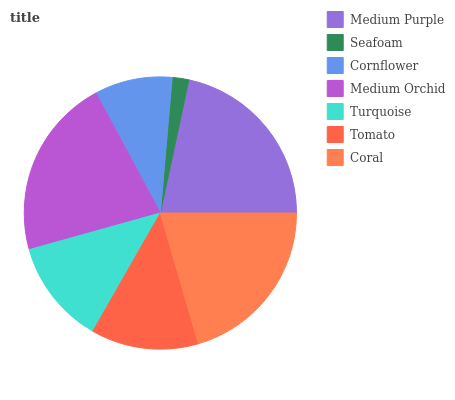Is Seafoam the minimum?
Answer yes or no. Yes. Is Medium Purple the maximum?
Answer yes or no. Yes. Is Cornflower the minimum?
Answer yes or no. No. Is Cornflower the maximum?
Answer yes or no. No. Is Cornflower greater than Seafoam?
Answer yes or no. Yes. Is Seafoam less than Cornflower?
Answer yes or no. Yes. Is Seafoam greater than Cornflower?
Answer yes or no. No. Is Cornflower less than Seafoam?
Answer yes or no. No. Is Tomato the high median?
Answer yes or no. Yes. Is Tomato the low median?
Answer yes or no. Yes. Is Medium Purple the high median?
Answer yes or no. No. Is Cornflower the low median?
Answer yes or no. No. 